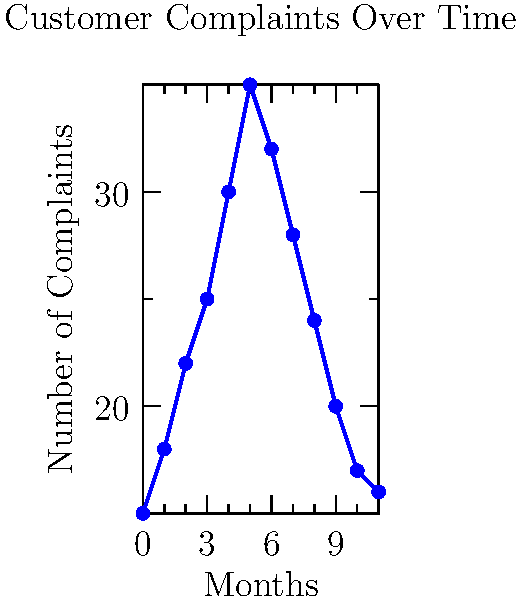Based on the line graph showing customer complaints over a 12-month period, what policy intervention would you recommend to address the peak in complaints, and why? To answer this question, let's analyze the graph step-by-step:

1. Observe the trend: The number of complaints increases from month 0 to month 5, then decreases from month 5 to month 11.

2. Identify the peak: The highest number of complaints occurs at month 5, with approximately 35 complaints.

3. Consider seasonality: The peak occurs in the middle of the year (assuming month 0 is January), which could correspond to the summer season.

4. Analyze potential causes: Summer months often see increased restaurant activity, potentially leading to:
   a) Longer wait times
   b) Overwhelmed staff
   c) Quality issues due to high volume

5. Policy intervention: Given this analysis, a suitable policy intervention would be to implement seasonal staffing regulations. This could include:
   a) Requiring restaurants to increase staff during peak seasons
   b) Mandating training programs for seasonal workers
   c) Setting guidelines for maximum wait times during busy periods

6. Justification: This policy would address the root causes of the increased complaints by ensuring restaurants are adequately staffed and prepared for the busy season, potentially reducing wait times and maintaining quality standards.
Answer: Implement seasonal staffing regulations to address peak complaint periods. 